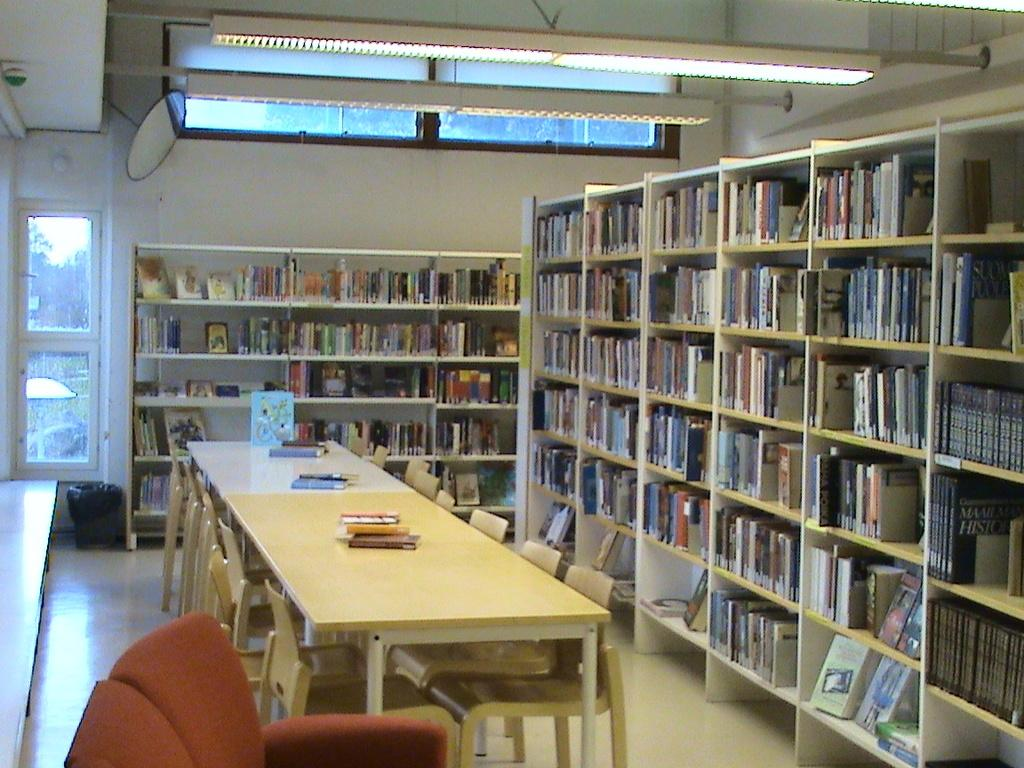<image>
Write a terse but informative summary of the picture. A library with many books including a black book that has History written on the cover. 